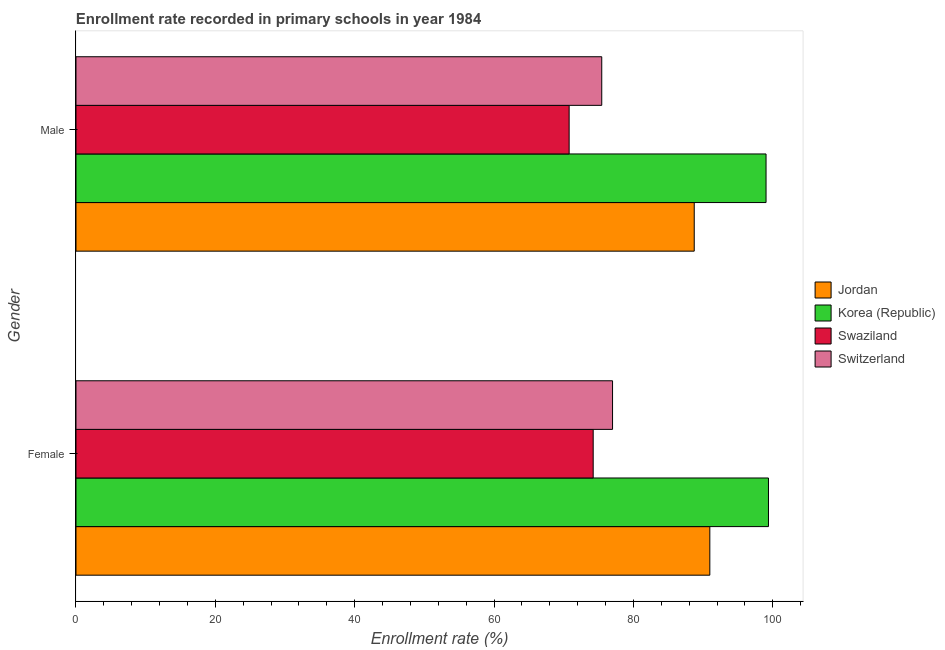How many groups of bars are there?
Provide a succinct answer. 2. Are the number of bars per tick equal to the number of legend labels?
Make the answer very short. Yes. What is the enrollment rate of male students in Korea (Republic)?
Ensure brevity in your answer.  99.03. Across all countries, what is the maximum enrollment rate of female students?
Provide a short and direct response. 99.38. Across all countries, what is the minimum enrollment rate of male students?
Offer a terse response. 70.77. In which country was the enrollment rate of female students maximum?
Provide a succinct answer. Korea (Republic). In which country was the enrollment rate of male students minimum?
Provide a succinct answer. Swaziland. What is the total enrollment rate of male students in the graph?
Offer a very short reply. 333.98. What is the difference between the enrollment rate of female students in Jordan and that in Switzerland?
Make the answer very short. 13.96. What is the difference between the enrollment rate of female students in Korea (Republic) and the enrollment rate of male students in Jordan?
Offer a terse response. 10.65. What is the average enrollment rate of male students per country?
Offer a very short reply. 83.5. What is the difference between the enrollment rate of female students and enrollment rate of male students in Jordan?
Offer a terse response. 2.24. What is the ratio of the enrollment rate of female students in Swaziland to that in Korea (Republic)?
Your answer should be compact. 0.75. Is the enrollment rate of female students in Korea (Republic) less than that in Jordan?
Your answer should be very brief. No. What does the 4th bar from the top in Male represents?
Offer a very short reply. Jordan. What does the 3rd bar from the bottom in Male represents?
Provide a succinct answer. Swaziland. Are all the bars in the graph horizontal?
Your answer should be compact. Yes. Are the values on the major ticks of X-axis written in scientific E-notation?
Your answer should be very brief. No. Does the graph contain grids?
Give a very brief answer. No. Where does the legend appear in the graph?
Keep it short and to the point. Center right. How are the legend labels stacked?
Your answer should be compact. Vertical. What is the title of the graph?
Offer a terse response. Enrollment rate recorded in primary schools in year 1984. Does "Croatia" appear as one of the legend labels in the graph?
Offer a terse response. No. What is the label or title of the X-axis?
Your response must be concise. Enrollment rate (%). What is the Enrollment rate (%) in Jordan in Female?
Your response must be concise. 90.96. What is the Enrollment rate (%) in Korea (Republic) in Female?
Offer a very short reply. 99.38. What is the Enrollment rate (%) in Swaziland in Female?
Provide a succinct answer. 74.22. What is the Enrollment rate (%) in Switzerland in Female?
Provide a short and direct response. 77. What is the Enrollment rate (%) of Jordan in Male?
Keep it short and to the point. 88.72. What is the Enrollment rate (%) of Korea (Republic) in Male?
Provide a succinct answer. 99.03. What is the Enrollment rate (%) of Swaziland in Male?
Provide a short and direct response. 70.77. What is the Enrollment rate (%) in Switzerland in Male?
Keep it short and to the point. 75.45. Across all Gender, what is the maximum Enrollment rate (%) in Jordan?
Make the answer very short. 90.96. Across all Gender, what is the maximum Enrollment rate (%) in Korea (Republic)?
Your answer should be very brief. 99.38. Across all Gender, what is the maximum Enrollment rate (%) of Swaziland?
Offer a terse response. 74.22. Across all Gender, what is the maximum Enrollment rate (%) of Switzerland?
Offer a terse response. 77. Across all Gender, what is the minimum Enrollment rate (%) in Jordan?
Provide a succinct answer. 88.72. Across all Gender, what is the minimum Enrollment rate (%) in Korea (Republic)?
Offer a terse response. 99.03. Across all Gender, what is the minimum Enrollment rate (%) in Swaziland?
Offer a terse response. 70.77. Across all Gender, what is the minimum Enrollment rate (%) of Switzerland?
Your answer should be very brief. 75.45. What is the total Enrollment rate (%) in Jordan in the graph?
Ensure brevity in your answer.  179.69. What is the total Enrollment rate (%) of Korea (Republic) in the graph?
Ensure brevity in your answer.  198.41. What is the total Enrollment rate (%) of Swaziland in the graph?
Make the answer very short. 145. What is the total Enrollment rate (%) in Switzerland in the graph?
Give a very brief answer. 152.46. What is the difference between the Enrollment rate (%) in Jordan in Female and that in Male?
Provide a succinct answer. 2.24. What is the difference between the Enrollment rate (%) in Korea (Republic) in Female and that in Male?
Your answer should be compact. 0.35. What is the difference between the Enrollment rate (%) in Swaziland in Female and that in Male?
Keep it short and to the point. 3.45. What is the difference between the Enrollment rate (%) in Switzerland in Female and that in Male?
Provide a short and direct response. 1.55. What is the difference between the Enrollment rate (%) of Jordan in Female and the Enrollment rate (%) of Korea (Republic) in Male?
Your answer should be very brief. -8.07. What is the difference between the Enrollment rate (%) in Jordan in Female and the Enrollment rate (%) in Swaziland in Male?
Offer a terse response. 20.19. What is the difference between the Enrollment rate (%) of Jordan in Female and the Enrollment rate (%) of Switzerland in Male?
Offer a very short reply. 15.51. What is the difference between the Enrollment rate (%) in Korea (Republic) in Female and the Enrollment rate (%) in Swaziland in Male?
Offer a terse response. 28.61. What is the difference between the Enrollment rate (%) of Korea (Republic) in Female and the Enrollment rate (%) of Switzerland in Male?
Your answer should be very brief. 23.92. What is the difference between the Enrollment rate (%) in Swaziland in Female and the Enrollment rate (%) in Switzerland in Male?
Keep it short and to the point. -1.23. What is the average Enrollment rate (%) in Jordan per Gender?
Provide a succinct answer. 89.84. What is the average Enrollment rate (%) in Korea (Republic) per Gender?
Ensure brevity in your answer.  99.2. What is the average Enrollment rate (%) in Swaziland per Gender?
Your response must be concise. 72.5. What is the average Enrollment rate (%) of Switzerland per Gender?
Keep it short and to the point. 76.23. What is the difference between the Enrollment rate (%) of Jordan and Enrollment rate (%) of Korea (Republic) in Female?
Your response must be concise. -8.42. What is the difference between the Enrollment rate (%) in Jordan and Enrollment rate (%) in Swaziland in Female?
Provide a short and direct response. 16.74. What is the difference between the Enrollment rate (%) in Jordan and Enrollment rate (%) in Switzerland in Female?
Give a very brief answer. 13.96. What is the difference between the Enrollment rate (%) of Korea (Republic) and Enrollment rate (%) of Swaziland in Female?
Make the answer very short. 25.15. What is the difference between the Enrollment rate (%) in Korea (Republic) and Enrollment rate (%) in Switzerland in Female?
Your answer should be compact. 22.38. What is the difference between the Enrollment rate (%) of Swaziland and Enrollment rate (%) of Switzerland in Female?
Your response must be concise. -2.78. What is the difference between the Enrollment rate (%) in Jordan and Enrollment rate (%) in Korea (Republic) in Male?
Offer a very short reply. -10.31. What is the difference between the Enrollment rate (%) of Jordan and Enrollment rate (%) of Swaziland in Male?
Offer a terse response. 17.95. What is the difference between the Enrollment rate (%) of Jordan and Enrollment rate (%) of Switzerland in Male?
Offer a very short reply. 13.27. What is the difference between the Enrollment rate (%) in Korea (Republic) and Enrollment rate (%) in Swaziland in Male?
Your answer should be compact. 28.26. What is the difference between the Enrollment rate (%) of Korea (Republic) and Enrollment rate (%) of Switzerland in Male?
Offer a terse response. 23.58. What is the difference between the Enrollment rate (%) of Swaziland and Enrollment rate (%) of Switzerland in Male?
Give a very brief answer. -4.68. What is the ratio of the Enrollment rate (%) of Jordan in Female to that in Male?
Give a very brief answer. 1.03. What is the ratio of the Enrollment rate (%) of Swaziland in Female to that in Male?
Offer a terse response. 1.05. What is the ratio of the Enrollment rate (%) of Switzerland in Female to that in Male?
Provide a short and direct response. 1.02. What is the difference between the highest and the second highest Enrollment rate (%) of Jordan?
Give a very brief answer. 2.24. What is the difference between the highest and the second highest Enrollment rate (%) in Korea (Republic)?
Offer a terse response. 0.35. What is the difference between the highest and the second highest Enrollment rate (%) of Swaziland?
Your response must be concise. 3.45. What is the difference between the highest and the second highest Enrollment rate (%) in Switzerland?
Provide a short and direct response. 1.55. What is the difference between the highest and the lowest Enrollment rate (%) in Jordan?
Offer a very short reply. 2.24. What is the difference between the highest and the lowest Enrollment rate (%) in Korea (Republic)?
Your answer should be very brief. 0.35. What is the difference between the highest and the lowest Enrollment rate (%) in Swaziland?
Provide a short and direct response. 3.45. What is the difference between the highest and the lowest Enrollment rate (%) in Switzerland?
Keep it short and to the point. 1.55. 